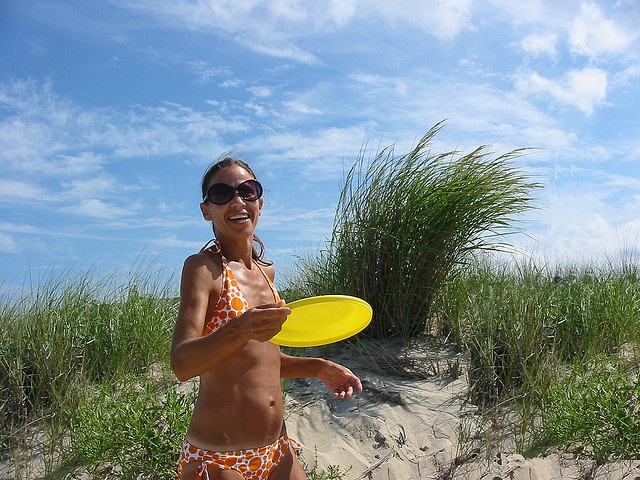Describe the objects in this image and their specific colors. I can see people in gray, maroon, brown, and black tones and frisbee in gray, gold, olive, and black tones in this image. 